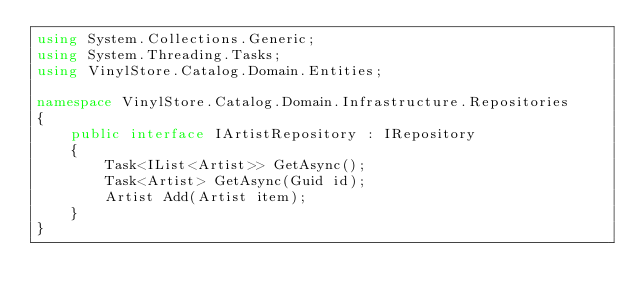Convert code to text. <code><loc_0><loc_0><loc_500><loc_500><_C#_>using System.Collections.Generic;
using System.Threading.Tasks;
using VinylStore.Catalog.Domain.Entities;

namespace VinylStore.Catalog.Domain.Infrastructure.Repositories
{
    public interface IArtistRepository : IRepository
    {
        Task<IList<Artist>> GetAsync();
        Task<Artist> GetAsync(Guid id);
        Artist Add(Artist item);
    }
}
</code> 